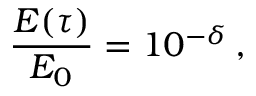<formula> <loc_0><loc_0><loc_500><loc_500>\frac { E ( \tau ) } { E _ { 0 } } = 1 0 ^ { - \delta } \, ,</formula> 